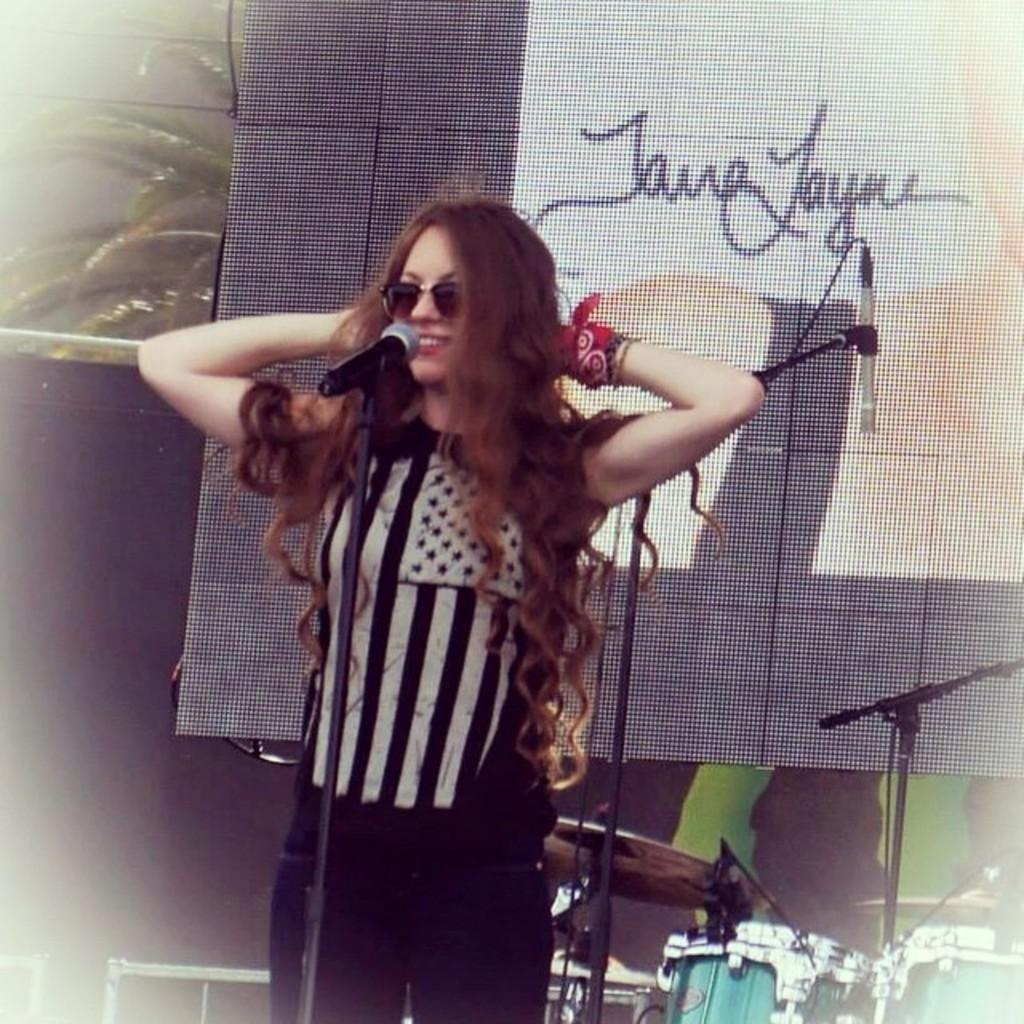What is the main subject of the image? There is a woman standing in the image. What is the woman standing on? The woman is standing on the floor. What object is in front of the woman? There is a microphone stand in front of the woman. What can be seen in the background of the image? There is a display screen, musical instruments, and plants in the background of the image. What type of toys can be seen scattered on the floor in the image? There are no toys visible in the image; the woman is standing on the floor with a microphone stand in front of her. 